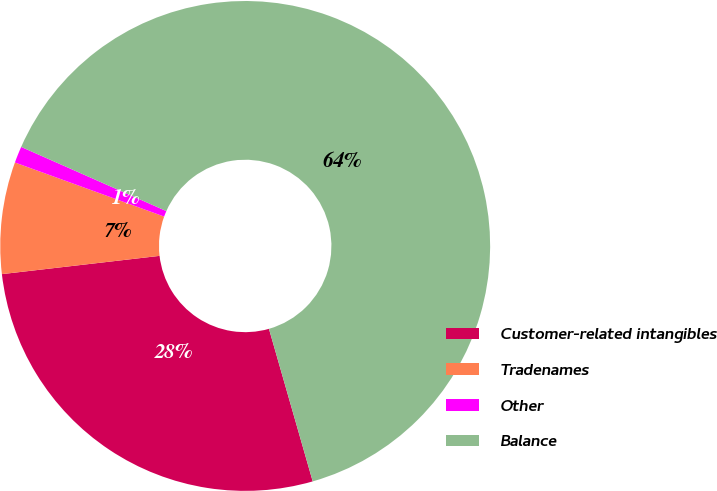Convert chart. <chart><loc_0><loc_0><loc_500><loc_500><pie_chart><fcel>Customer-related intangibles<fcel>Tradenames<fcel>Other<fcel>Balance<nl><fcel>27.61%<fcel>7.37%<fcel>1.09%<fcel>63.93%<nl></chart> 